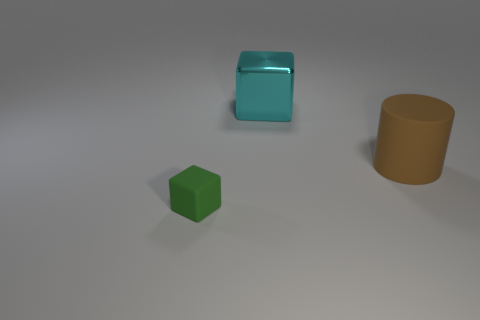Add 3 big cyan shiny objects. How many objects exist? 6 Subtract all cubes. How many objects are left? 1 Subtract all big things. Subtract all big yellow matte blocks. How many objects are left? 1 Add 2 cyan cubes. How many cyan cubes are left? 3 Add 1 cyan things. How many cyan things exist? 2 Subtract 0 purple cylinders. How many objects are left? 3 